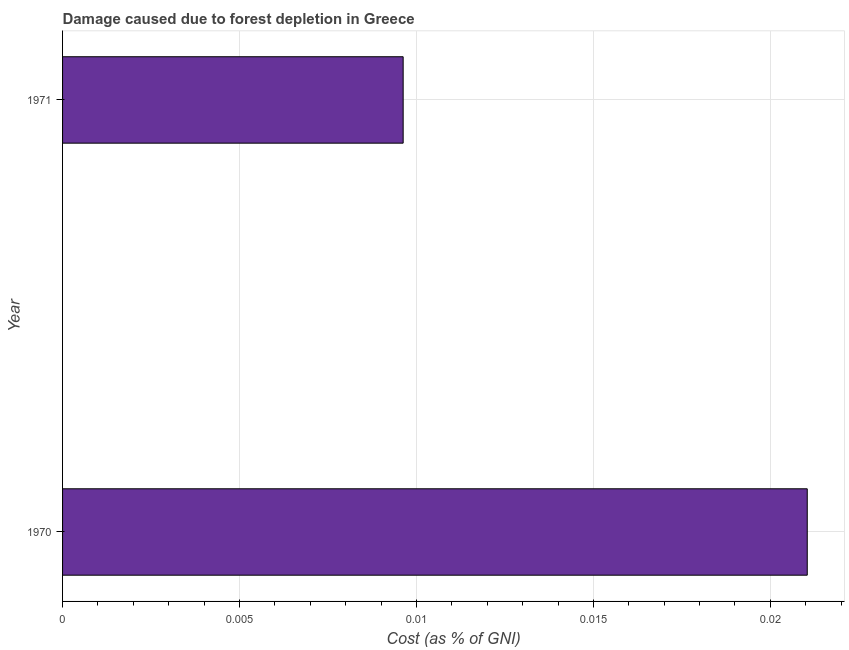Does the graph contain any zero values?
Provide a succinct answer. No. What is the title of the graph?
Provide a succinct answer. Damage caused due to forest depletion in Greece. What is the label or title of the X-axis?
Your response must be concise. Cost (as % of GNI). What is the label or title of the Y-axis?
Your response must be concise. Year. What is the damage caused due to forest depletion in 1970?
Your response must be concise. 0.02. Across all years, what is the maximum damage caused due to forest depletion?
Your answer should be compact. 0.02. Across all years, what is the minimum damage caused due to forest depletion?
Your answer should be compact. 0.01. In which year was the damage caused due to forest depletion maximum?
Your answer should be compact. 1970. In which year was the damage caused due to forest depletion minimum?
Give a very brief answer. 1971. What is the sum of the damage caused due to forest depletion?
Ensure brevity in your answer.  0.03. What is the difference between the damage caused due to forest depletion in 1970 and 1971?
Keep it short and to the point. 0.01. What is the average damage caused due to forest depletion per year?
Give a very brief answer. 0.01. What is the median damage caused due to forest depletion?
Keep it short and to the point. 0.02. Do a majority of the years between 1971 and 1970 (inclusive) have damage caused due to forest depletion greater than 0.018 %?
Keep it short and to the point. No. What is the ratio of the damage caused due to forest depletion in 1970 to that in 1971?
Keep it short and to the point. 2.19. Is the damage caused due to forest depletion in 1970 less than that in 1971?
Ensure brevity in your answer.  No. How many bars are there?
Make the answer very short. 2. Are all the bars in the graph horizontal?
Your answer should be very brief. Yes. How many years are there in the graph?
Ensure brevity in your answer.  2. What is the difference between two consecutive major ticks on the X-axis?
Your answer should be compact. 0.01. What is the Cost (as % of GNI) of 1970?
Keep it short and to the point. 0.02. What is the Cost (as % of GNI) of 1971?
Your answer should be compact. 0.01. What is the difference between the Cost (as % of GNI) in 1970 and 1971?
Ensure brevity in your answer.  0.01. What is the ratio of the Cost (as % of GNI) in 1970 to that in 1971?
Give a very brief answer. 2.19. 